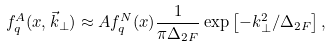<formula> <loc_0><loc_0><loc_500><loc_500>f _ { q } ^ { A } ( x , \vec { k } _ { \perp } ) \approx A f _ { q } ^ { N } ( x ) \frac { 1 } { \pi \Delta _ { 2 F } } \exp \left [ - k _ { \perp } ^ { 2 } / \Delta _ { 2 F } \right ] ,</formula> 